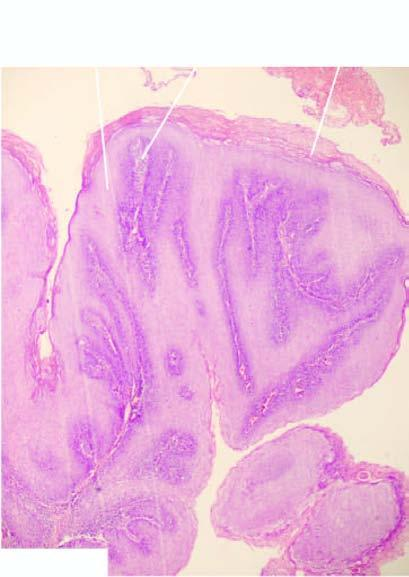what are covered with well oriented and orderly layers of squamous cells?
Answer the question using a single word or phrase. Papillae 